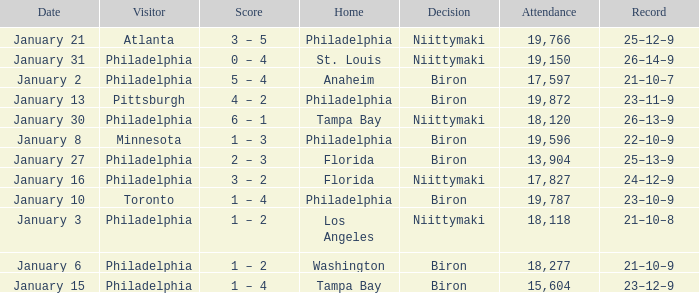What is the decision of the game on January 13? Biron. 